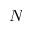Convert formula to latex. <formula><loc_0><loc_0><loc_500><loc_500>N</formula> 